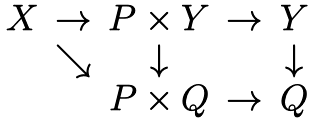Convert formula to latex. <formula><loc_0><loc_0><loc_500><loc_500>\begin{matrix} X & \to & P \times Y & \to & Y \\ & \searrow & \downarrow & & \downarrow \\ & & P \times Q & \to & Q \end{matrix}</formula> 